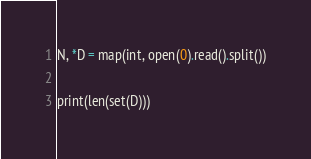Convert code to text. <code><loc_0><loc_0><loc_500><loc_500><_Python_>N, *D = map(int, open(0).read().split())

print(len(set(D)))</code> 